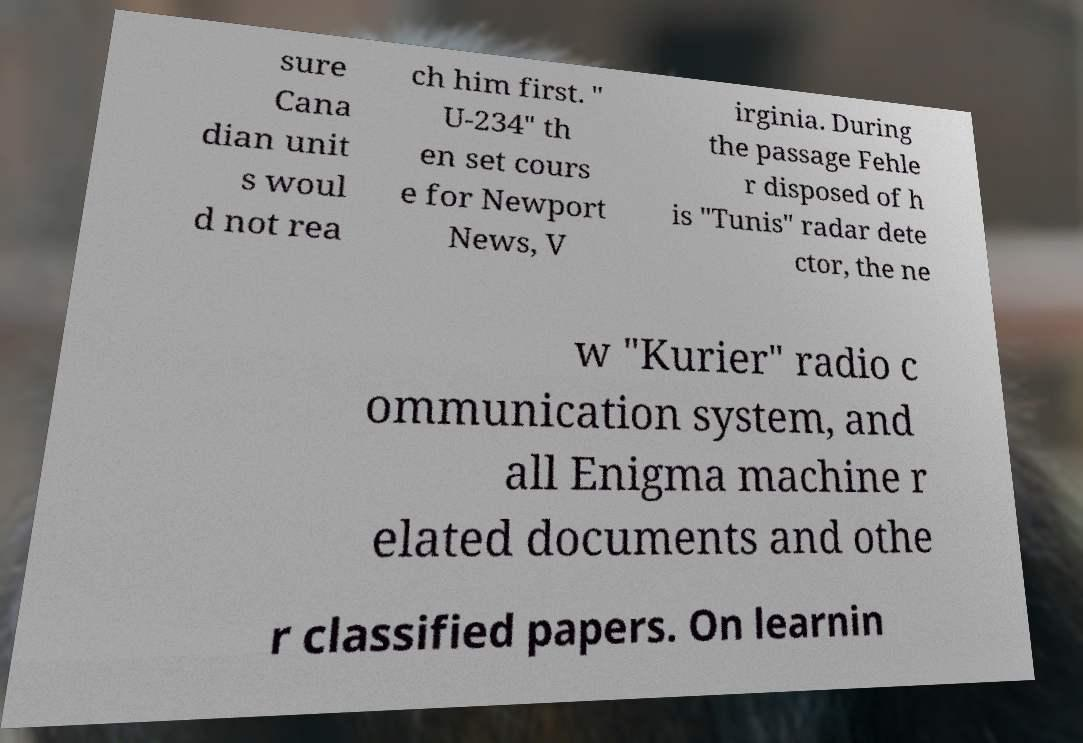Could you assist in decoding the text presented in this image and type it out clearly? sure Cana dian unit s woul d not rea ch him first. " U-234" th en set cours e for Newport News, V irginia. During the passage Fehle r disposed of h is "Tunis" radar dete ctor, the ne w "Kurier" radio c ommunication system, and all Enigma machine r elated documents and othe r classified papers. On learnin 